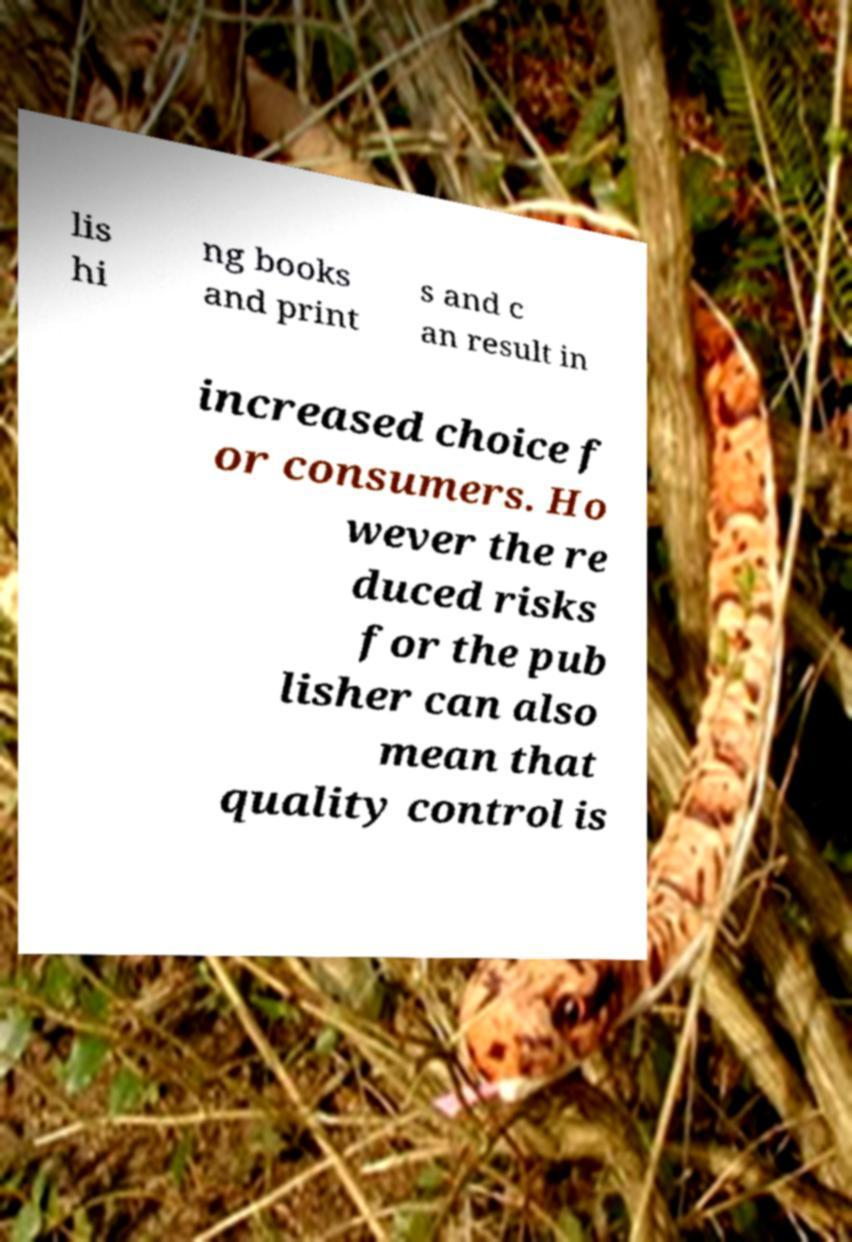Please read and relay the text visible in this image. What does it say? lis hi ng books and print s and c an result in increased choice f or consumers. Ho wever the re duced risks for the pub lisher can also mean that quality control is 